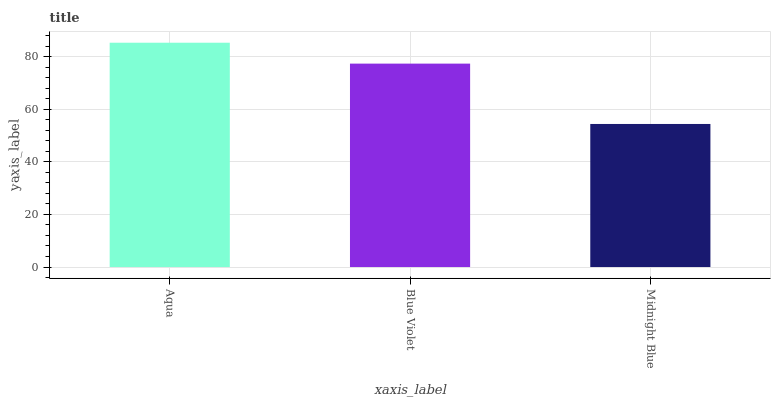Is Midnight Blue the minimum?
Answer yes or no. Yes. Is Aqua the maximum?
Answer yes or no. Yes. Is Blue Violet the minimum?
Answer yes or no. No. Is Blue Violet the maximum?
Answer yes or no. No. Is Aqua greater than Blue Violet?
Answer yes or no. Yes. Is Blue Violet less than Aqua?
Answer yes or no. Yes. Is Blue Violet greater than Aqua?
Answer yes or no. No. Is Aqua less than Blue Violet?
Answer yes or no. No. Is Blue Violet the high median?
Answer yes or no. Yes. Is Blue Violet the low median?
Answer yes or no. Yes. Is Midnight Blue the high median?
Answer yes or no. No. Is Midnight Blue the low median?
Answer yes or no. No. 